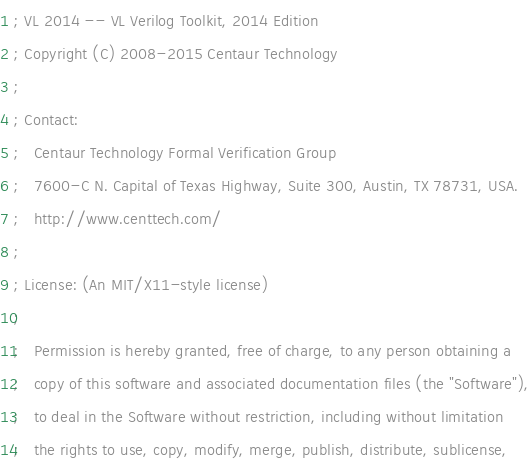<code> <loc_0><loc_0><loc_500><loc_500><_Lisp_>; VL 2014 -- VL Verilog Toolkit, 2014 Edition
; Copyright (C) 2008-2015 Centaur Technology
;
; Contact:
;   Centaur Technology Formal Verification Group
;   7600-C N. Capital of Texas Highway, Suite 300, Austin, TX 78731, USA.
;   http://www.centtech.com/
;
; License: (An MIT/X11-style license)
;
;   Permission is hereby granted, free of charge, to any person obtaining a
;   copy of this software and associated documentation files (the "Software"),
;   to deal in the Software without restriction, including without limitation
;   the rights to use, copy, modify, merge, publish, distribute, sublicense,</code> 